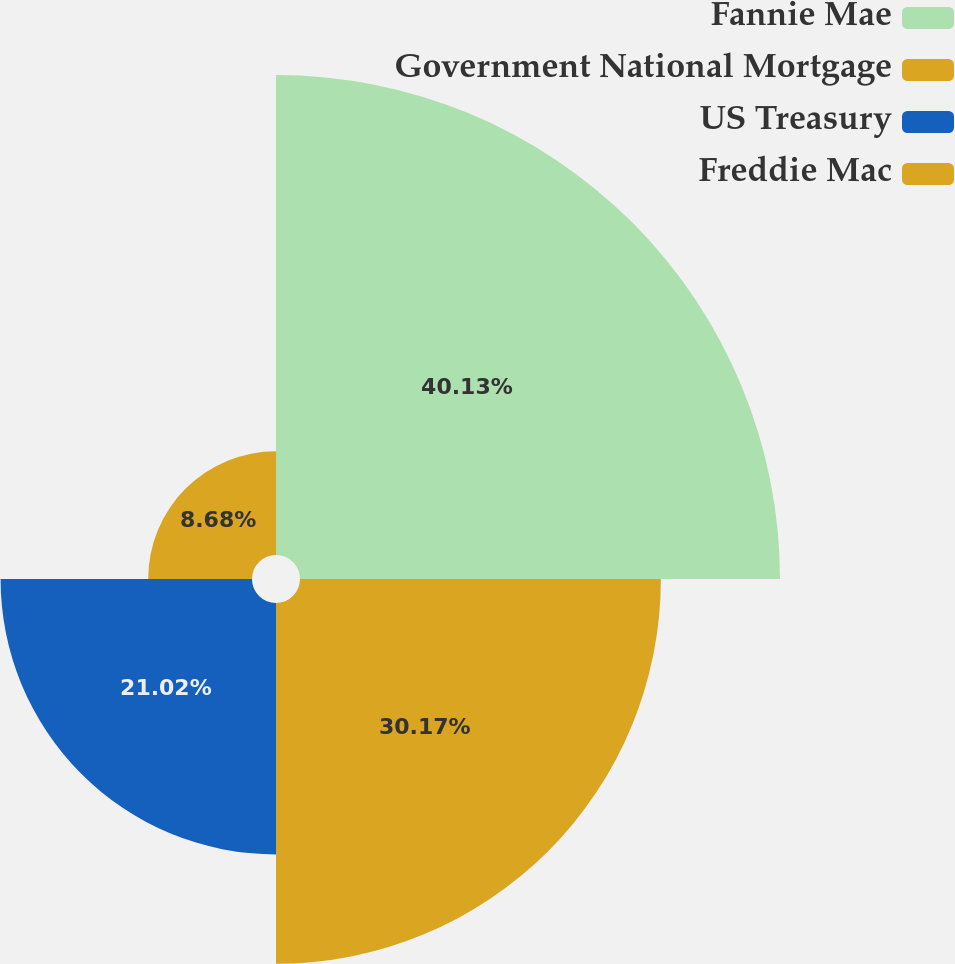Convert chart. <chart><loc_0><loc_0><loc_500><loc_500><pie_chart><fcel>Fannie Mae<fcel>Government National Mortgage<fcel>US Treasury<fcel>Freddie Mac<nl><fcel>40.13%<fcel>30.17%<fcel>21.02%<fcel>8.68%<nl></chart> 